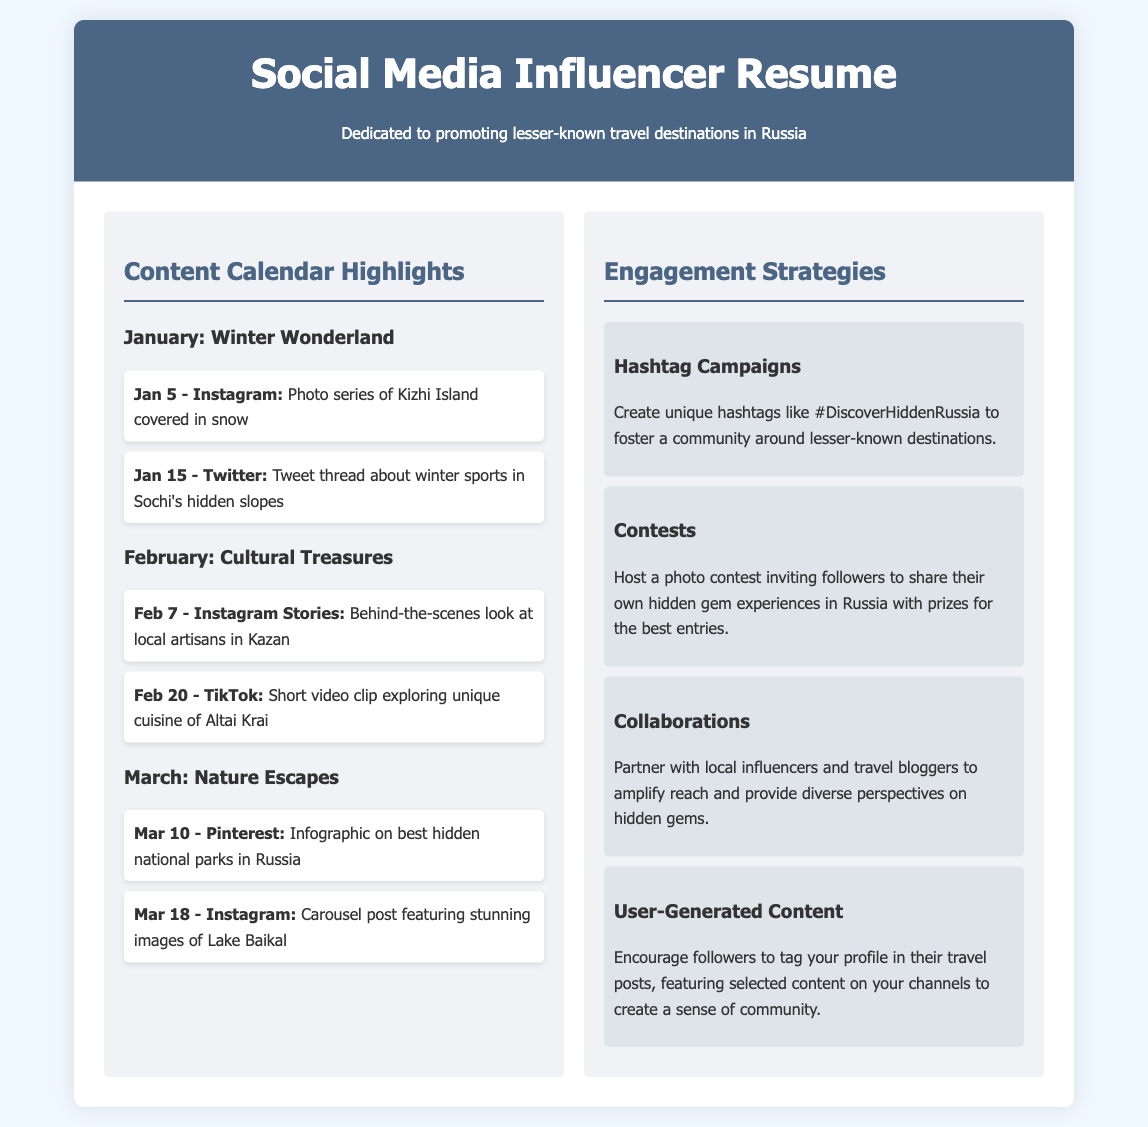What is the primary focus of the resume? The primary focus of the resume is dedicated to promoting lesser-known travel destinations in Russia.
Answer: promoting lesser-known travel destinations in Russia What is the first post idea for January? The first post idea for January is a photo series of Kizhi Island covered in snow.
Answer: Photo series of Kizhi Island covered in snow On what date is the tweet thread about winter sports scheduled? The tweet thread about winter sports is scheduled for January 15.
Answer: January 15 What is one unique hashtag mentioned in the engagement strategies? One unique hashtag mentioned is #DiscoverHiddenRussia.
Answer: #DiscoverHiddenRussia What platform is the infographic on hidden national parks planned for? The infographic on hidden national parks is planned for Pinterest.
Answer: Pinterest How many engagement strategies are listed in the document? There are four engagement strategies listed in the document.
Answer: four What type of content is scheduled for February 20? A short video clip exploring unique cuisine of Altai Krai is scheduled for February 20.
Answer: Short video clip exploring unique cuisine of Altai Krai What month features a theme of "Nature Escapes"? The theme of "Nature Escapes" is featured in March.
Answer: March 